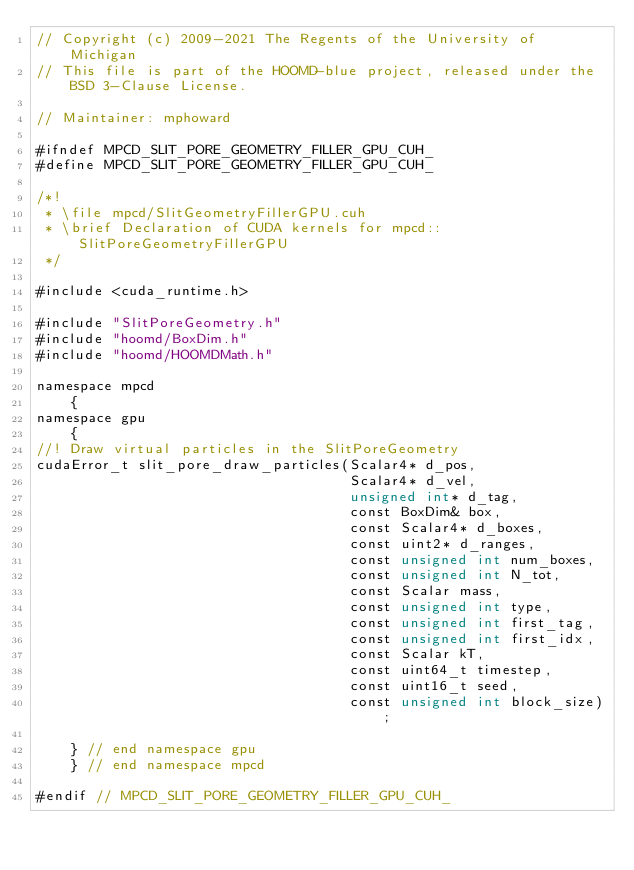<code> <loc_0><loc_0><loc_500><loc_500><_Cuda_>// Copyright (c) 2009-2021 The Regents of the University of Michigan
// This file is part of the HOOMD-blue project, released under the BSD 3-Clause License.

// Maintainer: mphoward

#ifndef MPCD_SLIT_PORE_GEOMETRY_FILLER_GPU_CUH_
#define MPCD_SLIT_PORE_GEOMETRY_FILLER_GPU_CUH_

/*!
 * \file mpcd/SlitGeometryFillerGPU.cuh
 * \brief Declaration of CUDA kernels for mpcd::SlitPoreGeometryFillerGPU
 */

#include <cuda_runtime.h>

#include "SlitPoreGeometry.h"
#include "hoomd/BoxDim.h"
#include "hoomd/HOOMDMath.h"

namespace mpcd
    {
namespace gpu
    {
//! Draw virtual particles in the SlitPoreGeometry
cudaError_t slit_pore_draw_particles(Scalar4* d_pos,
                                     Scalar4* d_vel,
                                     unsigned int* d_tag,
                                     const BoxDim& box,
                                     const Scalar4* d_boxes,
                                     const uint2* d_ranges,
                                     const unsigned int num_boxes,
                                     const unsigned int N_tot,
                                     const Scalar mass,
                                     const unsigned int type,
                                     const unsigned int first_tag,
                                     const unsigned int first_idx,
                                     const Scalar kT,
                                     const uint64_t timestep,
                                     const uint16_t seed,
                                     const unsigned int block_size);

    } // end namespace gpu
    } // end namespace mpcd

#endif // MPCD_SLIT_PORE_GEOMETRY_FILLER_GPU_CUH_
</code> 